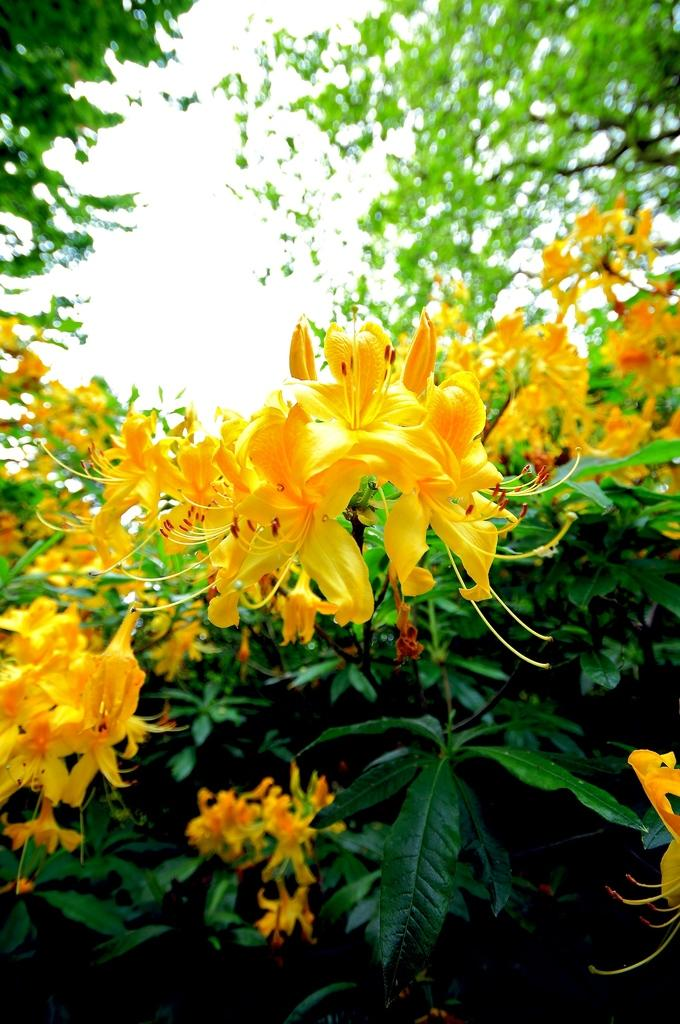What types of vegetation can be seen in the foreground of the image? There are flowers and plants in the foreground of the image. What can be seen in the background of the image? There are trees in the background of the image. What type of bait is being used to catch fish in the image? There is no bait or fishing activity present in the image; it features flowers, plants, and trees. Can you see any blood in the image? There is no blood or any indication of injury or violence in the image. 